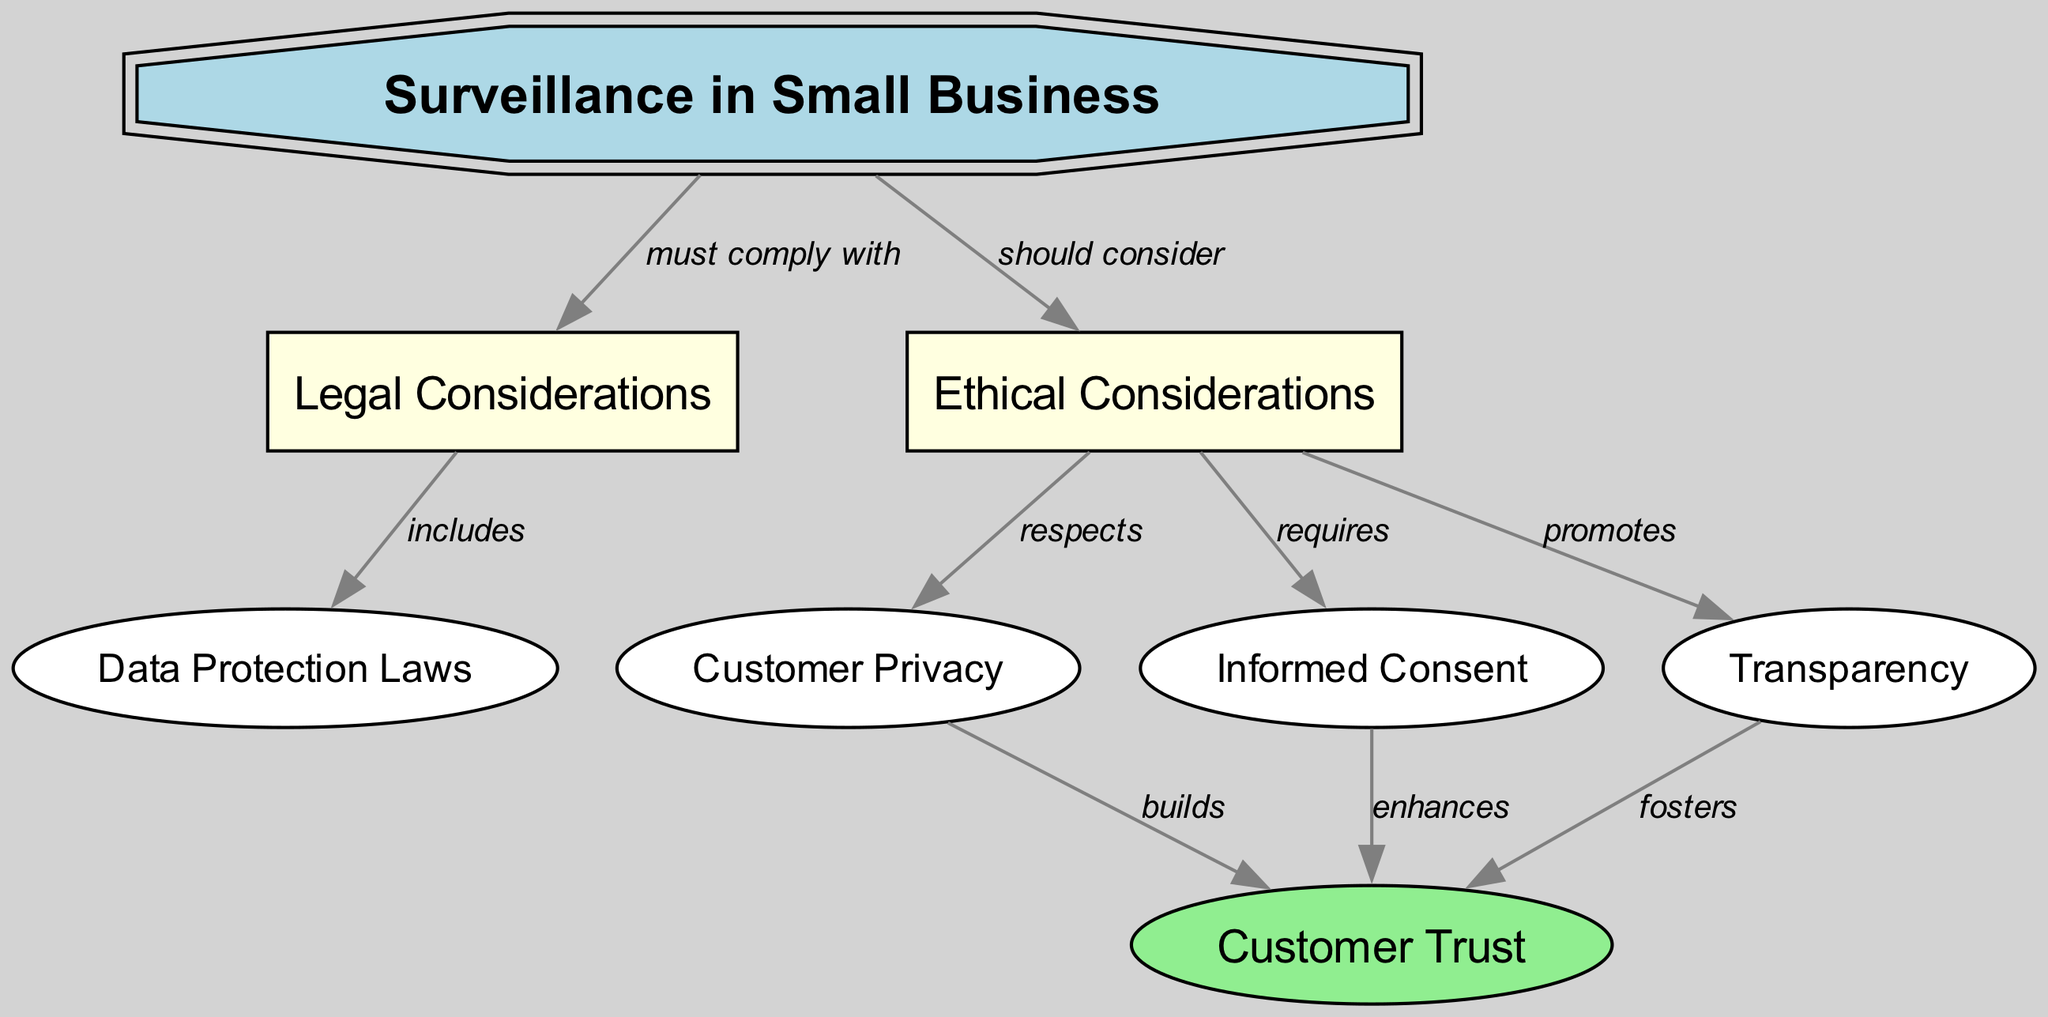What are the two main categories of considerations shown in the diagram? The diagram clearly identifies two main nodes, which are "Legal Considerations" and "Ethical Considerations", as categories under the central theme of "Surveillance in Small Business".
Answer: Legal and Ethical Considerations How many edges are there in the diagram? By counting the connections (edges) that show relationships between the nodes, we find that there are a total of eight edges in the diagram that connect various concepts.
Answer: Eight What does surveillance in small business 'must comply with'? The diagram indicates that surveillance in small business 'must comply with' the legal considerations, as depicted by the directed edge between those two nodes.
Answer: Legal Considerations What enhances customer trust according to the ethical considerations? The diagram presents a directed edge from "Informed Consent" to "Customer Trust", indicating that the ethical consideration of obtaining informed consent enhances customer trust.
Answer: Informed Consent What does ethical consideration promote that is linked to customer trust? The diagram highlights that ethical considerations 'promote' transparency, which is linked to customer trust as indicated by the direct connection in the diagram.
Answer: Transparency How does customer privacy influence customer trust? The diagram shows a relationship indicating that customer privacy builds customer trust, which is captured in the directed connection from "Customer Privacy" to "Customer Trust".
Answer: Builds What legal aspect is included under legal considerations? Referring to the diagram, "Data Protection Laws" is specifically mentioned as an inclusion under the legal considerations, as noted by the directed edge from "Legal Considerations" to "Data Protection Laws".
Answer: Data Protection Laws What ethical obligation requires involvement of consent in surveillance? The diagram makes it clear that ethical considerations 'require' informed consent for surveillance practices, establishing a direct relationship between the ethical and consent nodes.
Answer: Informed Consent Which element found in the diagram promotes trust through transparency? The connection from "Transparency" to "Customer Trust" in the diagram indicates that transparency is a factor that fosters trust among customers.
Answer: Transparency 